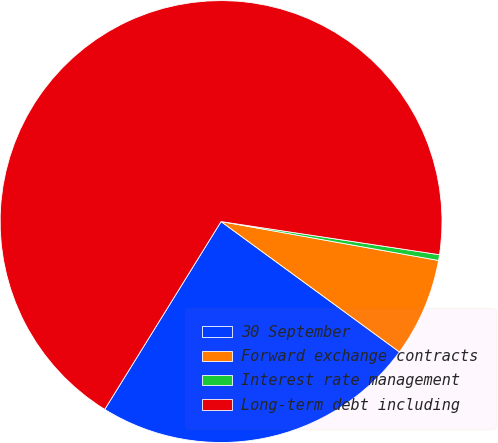Convert chart to OTSL. <chart><loc_0><loc_0><loc_500><loc_500><pie_chart><fcel>30 September<fcel>Forward exchange contracts<fcel>Interest rate management<fcel>Long-term debt including<nl><fcel>23.78%<fcel>7.23%<fcel>0.42%<fcel>68.57%<nl></chart> 